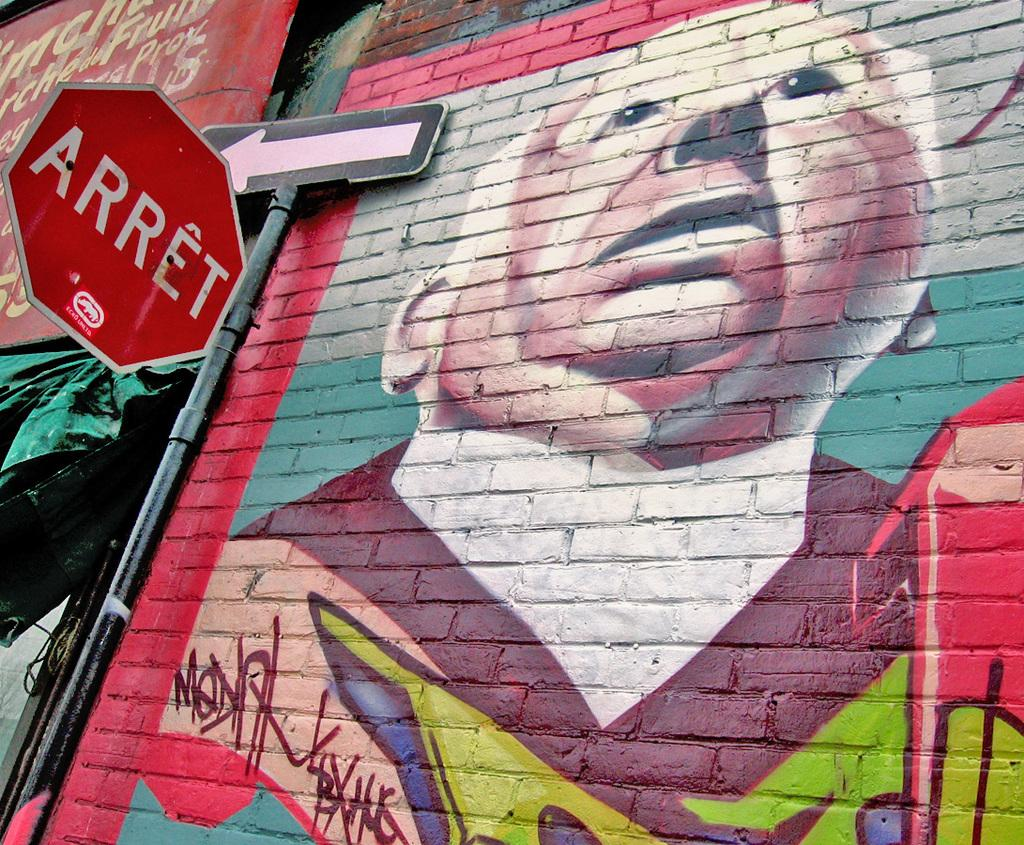<image>
Relay a brief, clear account of the picture shown. a brickwall painting of Alfred Hitchcock with a octogon sign saying ARRET 